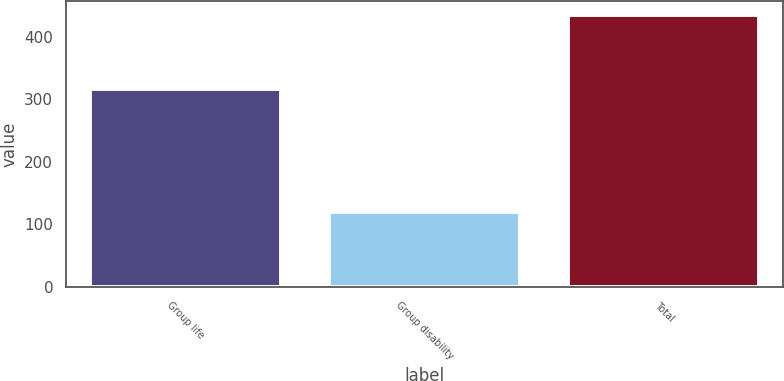<chart> <loc_0><loc_0><loc_500><loc_500><bar_chart><fcel>Group life<fcel>Group disability<fcel>Total<nl><fcel>316<fcel>119<fcel>435<nl></chart> 